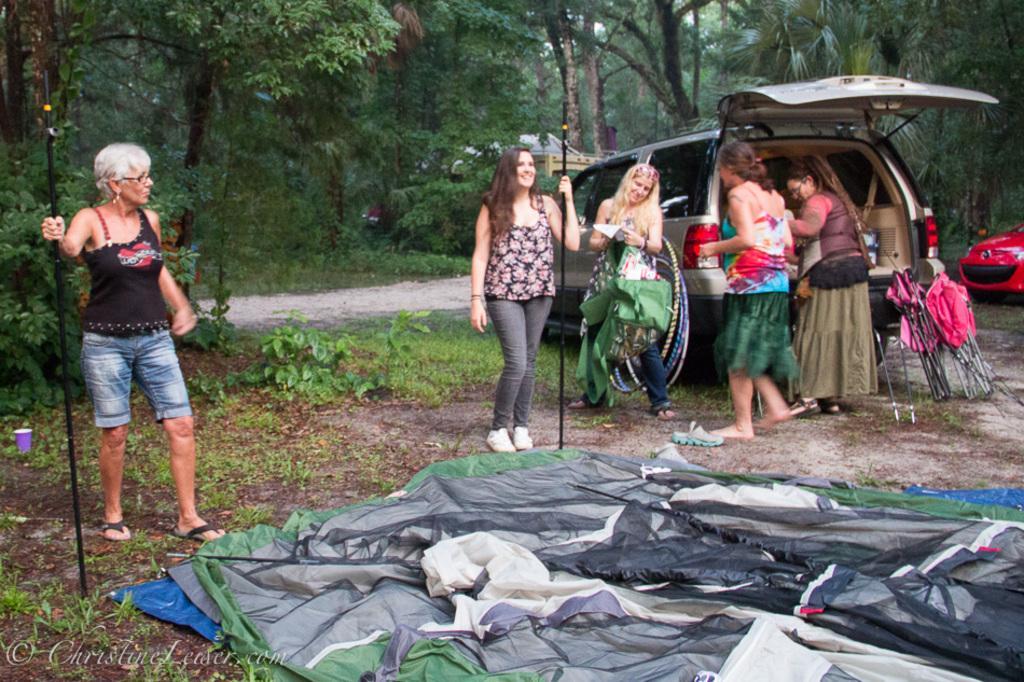Describe this image in one or two sentences. In this image we can see few people near a vehicle. There are few people holding some objects in their hand. A person is standing and holding an object at the left side of the image. There are many trees and plants in the image. There are few vehicles in the image. There are few objects on the ground. 